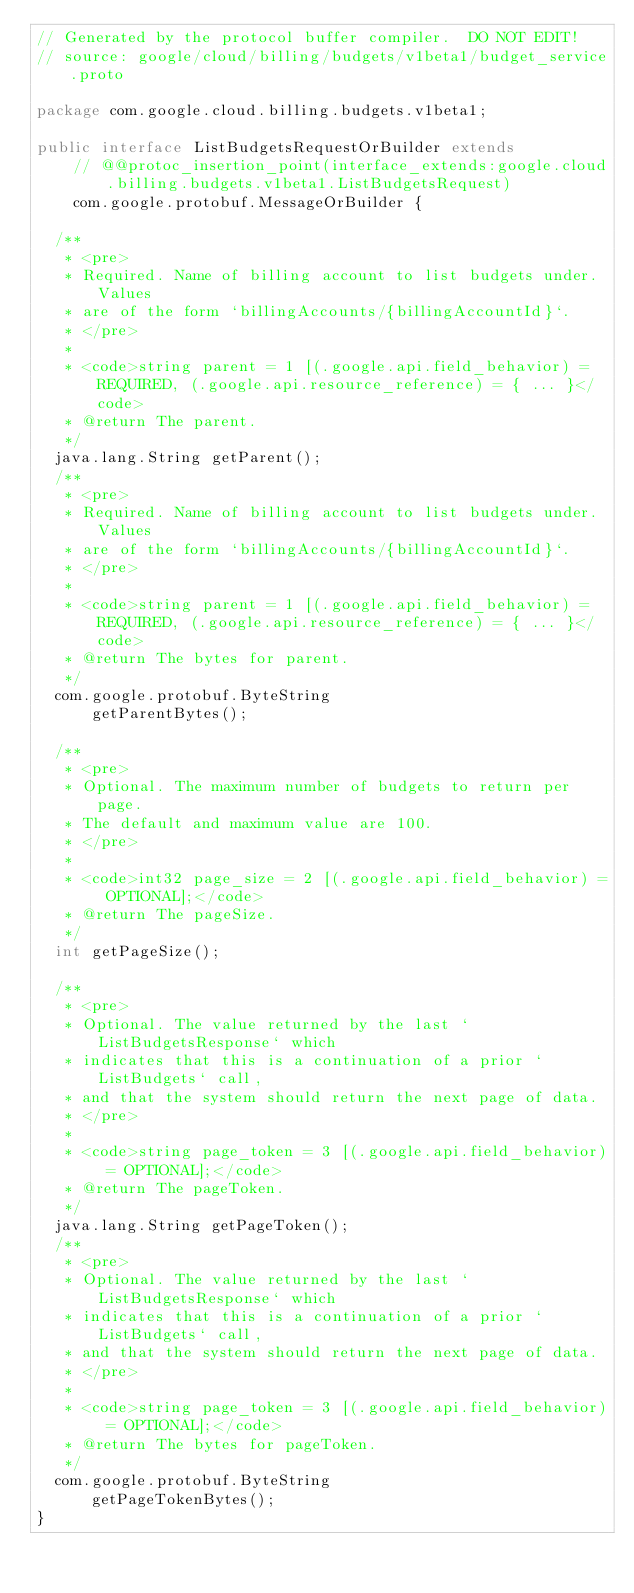Convert code to text. <code><loc_0><loc_0><loc_500><loc_500><_Java_>// Generated by the protocol buffer compiler.  DO NOT EDIT!
// source: google/cloud/billing/budgets/v1beta1/budget_service.proto

package com.google.cloud.billing.budgets.v1beta1;

public interface ListBudgetsRequestOrBuilder extends
    // @@protoc_insertion_point(interface_extends:google.cloud.billing.budgets.v1beta1.ListBudgetsRequest)
    com.google.protobuf.MessageOrBuilder {

  /**
   * <pre>
   * Required. Name of billing account to list budgets under. Values
   * are of the form `billingAccounts/{billingAccountId}`.
   * </pre>
   *
   * <code>string parent = 1 [(.google.api.field_behavior) = REQUIRED, (.google.api.resource_reference) = { ... }</code>
   * @return The parent.
   */
  java.lang.String getParent();
  /**
   * <pre>
   * Required. Name of billing account to list budgets under. Values
   * are of the form `billingAccounts/{billingAccountId}`.
   * </pre>
   *
   * <code>string parent = 1 [(.google.api.field_behavior) = REQUIRED, (.google.api.resource_reference) = { ... }</code>
   * @return The bytes for parent.
   */
  com.google.protobuf.ByteString
      getParentBytes();

  /**
   * <pre>
   * Optional. The maximum number of budgets to return per page.
   * The default and maximum value are 100.
   * </pre>
   *
   * <code>int32 page_size = 2 [(.google.api.field_behavior) = OPTIONAL];</code>
   * @return The pageSize.
   */
  int getPageSize();

  /**
   * <pre>
   * Optional. The value returned by the last `ListBudgetsResponse` which
   * indicates that this is a continuation of a prior `ListBudgets` call,
   * and that the system should return the next page of data.
   * </pre>
   *
   * <code>string page_token = 3 [(.google.api.field_behavior) = OPTIONAL];</code>
   * @return The pageToken.
   */
  java.lang.String getPageToken();
  /**
   * <pre>
   * Optional. The value returned by the last `ListBudgetsResponse` which
   * indicates that this is a continuation of a prior `ListBudgets` call,
   * and that the system should return the next page of data.
   * </pre>
   *
   * <code>string page_token = 3 [(.google.api.field_behavior) = OPTIONAL];</code>
   * @return The bytes for pageToken.
   */
  com.google.protobuf.ByteString
      getPageTokenBytes();
}
</code> 